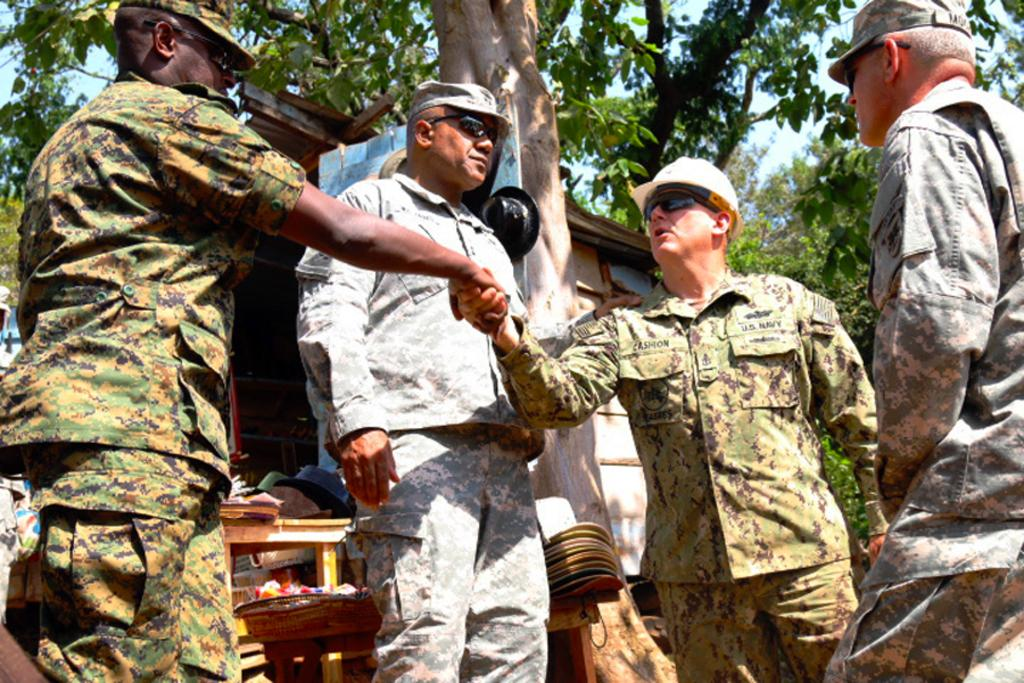How many men are in the image? There are four men in the image. What are the men wearing on their heads? Each man is wearing a cap. What are the men wearing to protect their eyes? Each man is wearing goggles. What can be seen in the background of the image? There is a basket, tables, a shed, some objects, trees, and the sky visible in the background of the image. What type of work are the men doing in the image? The image does not provide any information about the men's work or activities. Can you describe the type of shade provided by the trees in the image? The image does not show any specific type of shade provided by the trees; it only shows the trees in the background. 